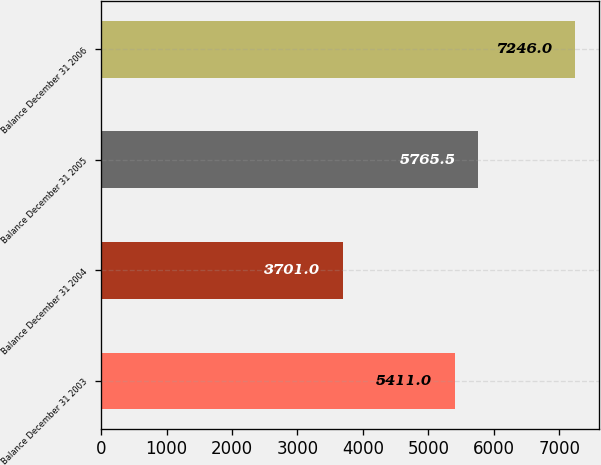Convert chart. <chart><loc_0><loc_0><loc_500><loc_500><bar_chart><fcel>Balance December 31 2003<fcel>Balance December 31 2004<fcel>Balance December 31 2005<fcel>Balance December 31 2006<nl><fcel>5411<fcel>3701<fcel>5765.5<fcel>7246<nl></chart> 